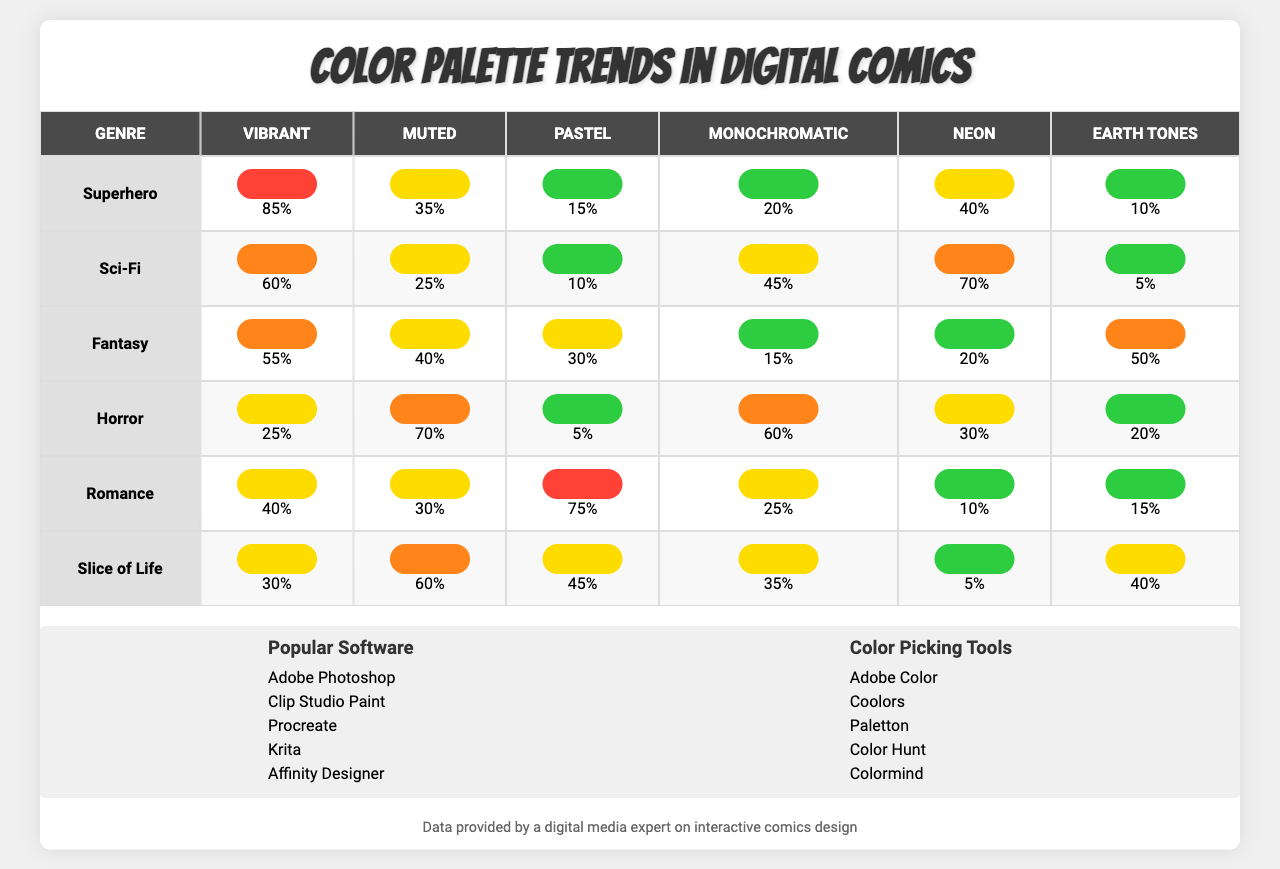What is the color palette percentage for "Vibrant" in the "Superhero" genre? The table shows that the percentage for "Vibrant" in the "Superhero" genre is listed as 85%.
Answer: 85% Which genre has the highest percentage of "Pastel" colors? By examining the table, we can see that "Romance" has the highest percentage of "Pastel" colors with 75%.
Answer: Romance (75%) What is the difference in percentage for "Earth Tones" between "Fantasy" and "Horror"? The percentage for "Earth Tones" in "Fantasy" is 50%, while in "Horror" it is 20%. The difference is 50% - 20% = 30%.
Answer: 30% Is the "Neon" color palette used more in the "Sci-Fi" genre than in "Slice of Life"? The "Neon" percentage for "Sci-Fi" is 70%, and for "Slice of Life," it is 5%. 70% is greater than 5%, confirming that "Neon" is used more in "Sci-Fi."
Answer: Yes What is the average percentage of "Muted" colors across all genres listed? The percentages of "Muted" colors are 35%, 25%, 40%, 70%, 30%, and 60%. Adding them gives 35 + 25 + 40 + 70 + 30 + 60 = 260, and dividing by 6 (number of genres) gives an average of 43.33%.
Answer: 43.33% What genre has the lowest usage of "Vibrant" colors and what is that percentage? Looking through the table, "Horror" has the lowest percentage of "Vibrant" colors, which is 25%.
Answer: Horror (25%) Comparing "Monochromatic" colors, which genre has a higher percentage: "Slice of Life" or "Sci-Fi"? The "Monochromatic" percentage for "Slice of Life" is 35% while for "Sci-Fi" it is 45%. Since 45% is greater than 35%, "Sci-Fi" has a higher percentage.
Answer: Sci-Fi (45%) If we sum the "Neon" percentages across all genres, what is the total? The "Neon" percentages are 40%, 70%, 20%, 30%, 10%, and 5%. Adding these together gives 40 + 70 + 20 + 30 + 10 + 5 = 175%.
Answer: 175% Which color palette appears the least in the "Romance" genre? The "Romance" genre has the lowest percentage for "Neon," which is 10%.
Answer: Neon (10%) In terms of color palette popularity, which genre uses "Earth Tones" the most? Analyzing the table, "Fantasy" has a higher percentage of "Earth Tones," which is 50%.
Answer: Fantasy (50%) If we look at the "Vibrant" and "Muted" colors for "Superhero," what is the sum of their percentages? The "Vibrant" percentage for "Superhero" is 85% and the "Muted" percentage is 35%. Adding these gives 85% + 35% = 120%.
Answer: 120% 